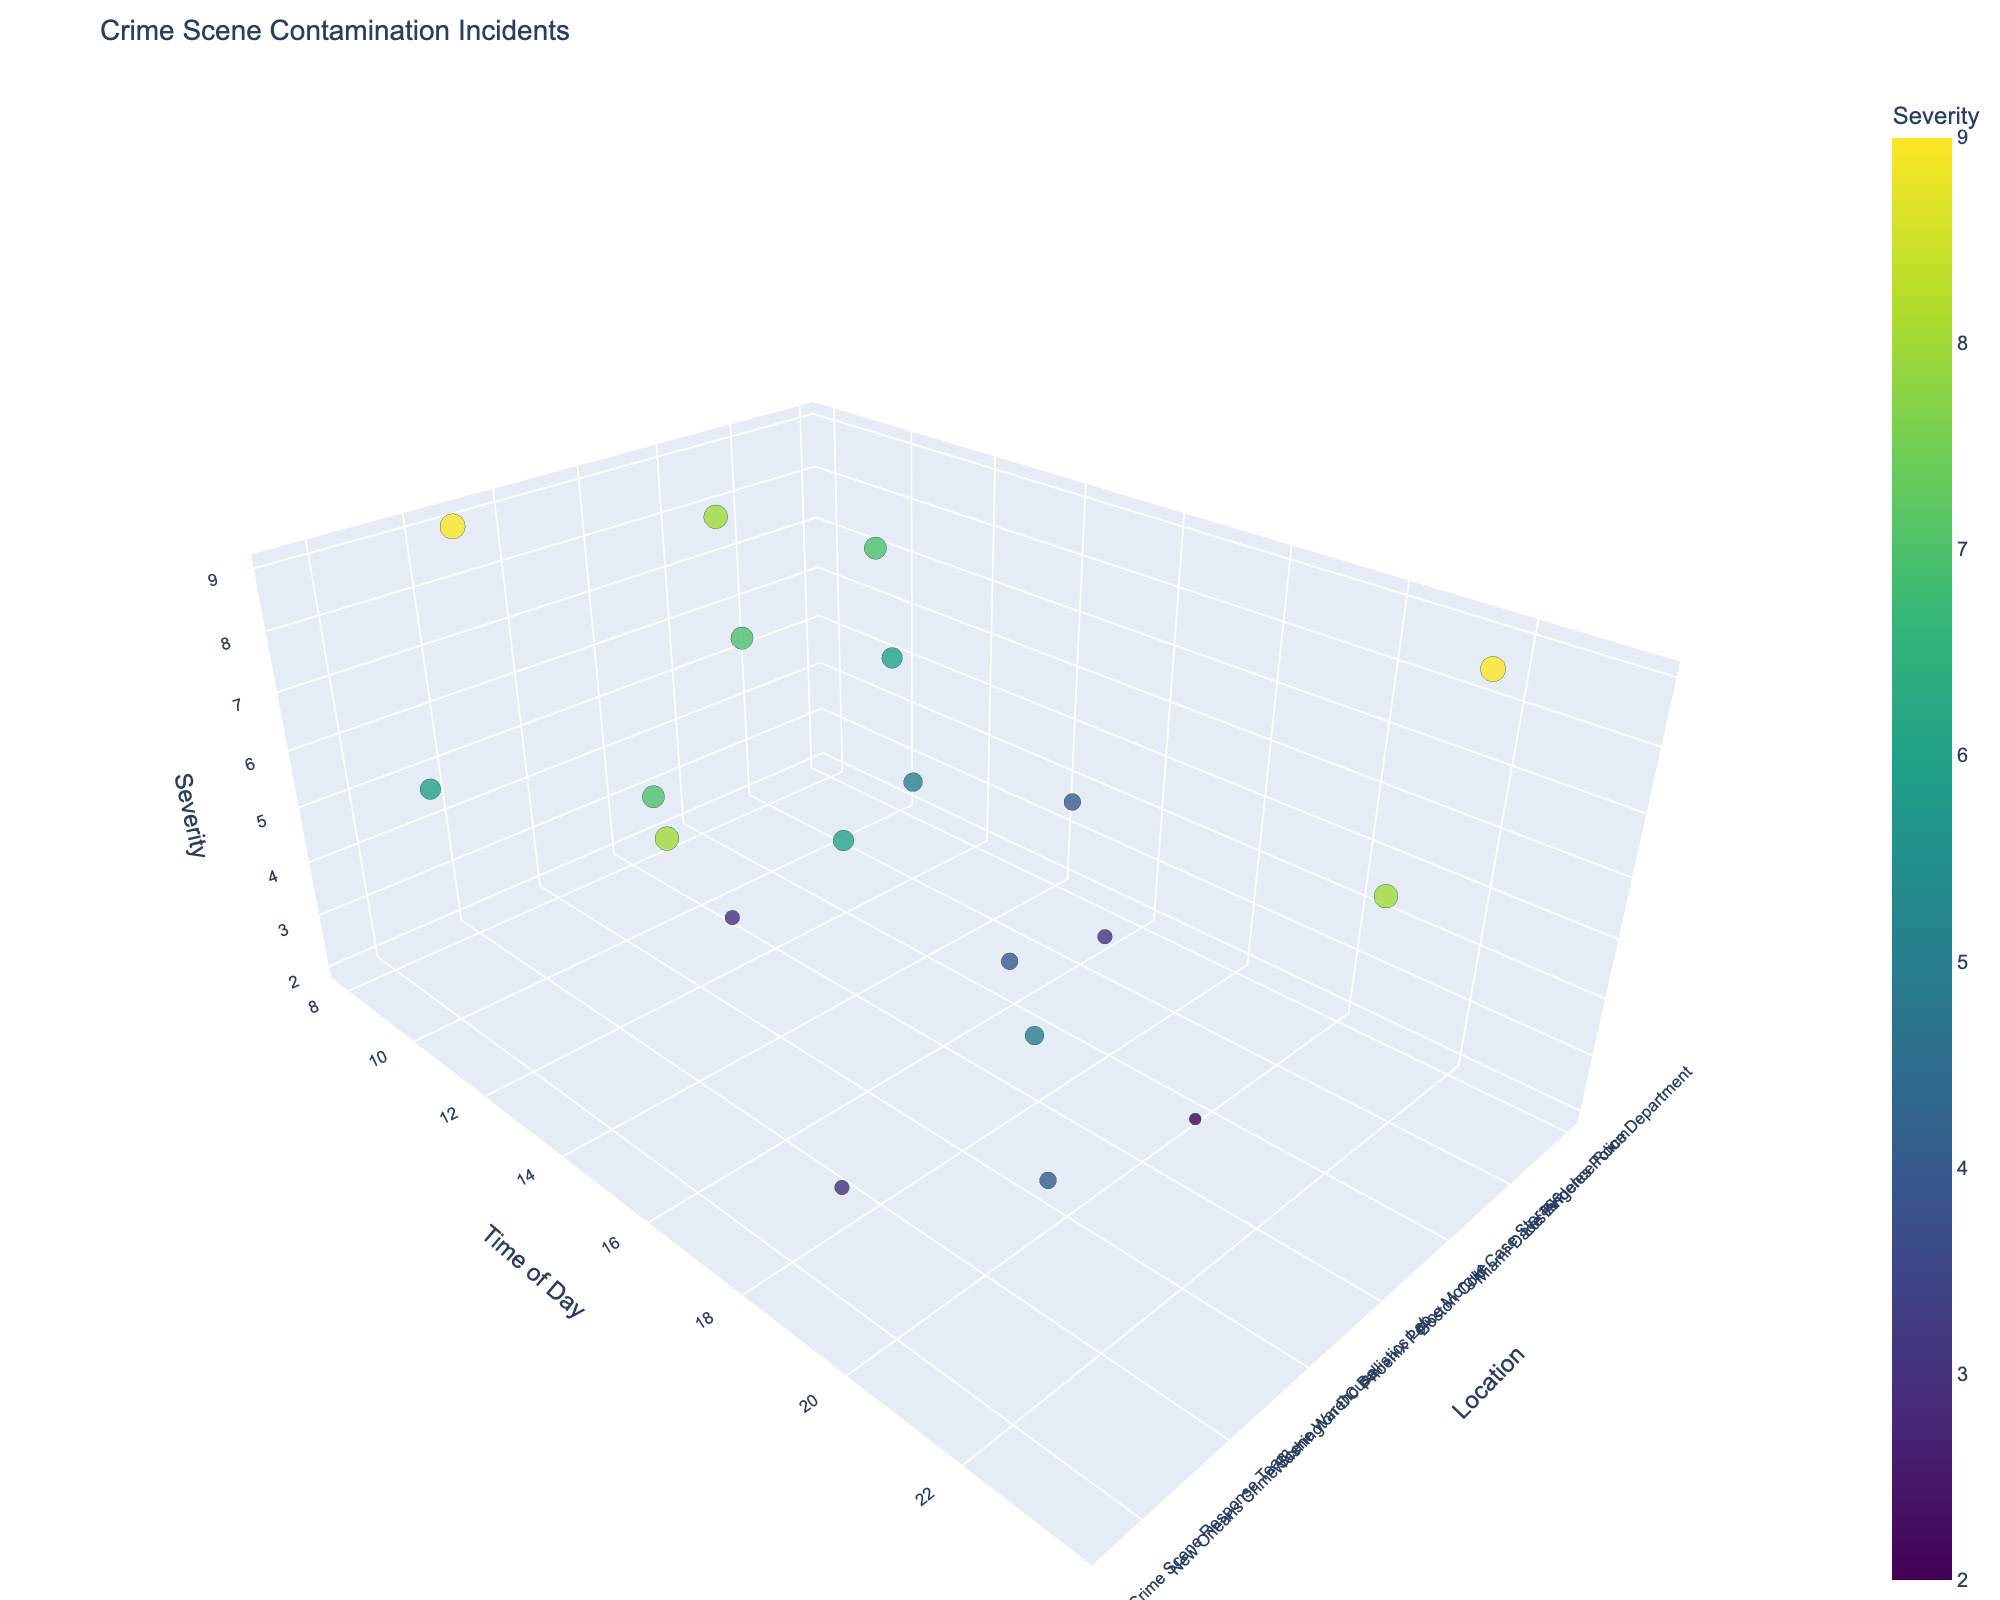What is the title of the plot? The title of the plot is found at the top of the figure.
Answer: Crime Scene Contamination Incidents How many data points are represented in the plot? Count the number of unique points scattered in the 3D plot.
Answer: 20 Which location has the highest severity level? Look for the highest value on the Z-axis and identify the corresponding location on the X-axis.
Answer: New York Crime Scene Unit What is the time range for contamination incidents? Observe the Y-axis and note the earliest and latest times.
Answer: 07:55 to 23:30 Which incident occurred earliest in the day? Identify the data point that is lowest on the Time of Day (Y-axis).
Answer: Philadelphia DNA Analysis Lab Which incident had the latest occurrence time? Find the highest value on the Time of Day (Y-axis).
Answer: San Francisco CSI Unit 